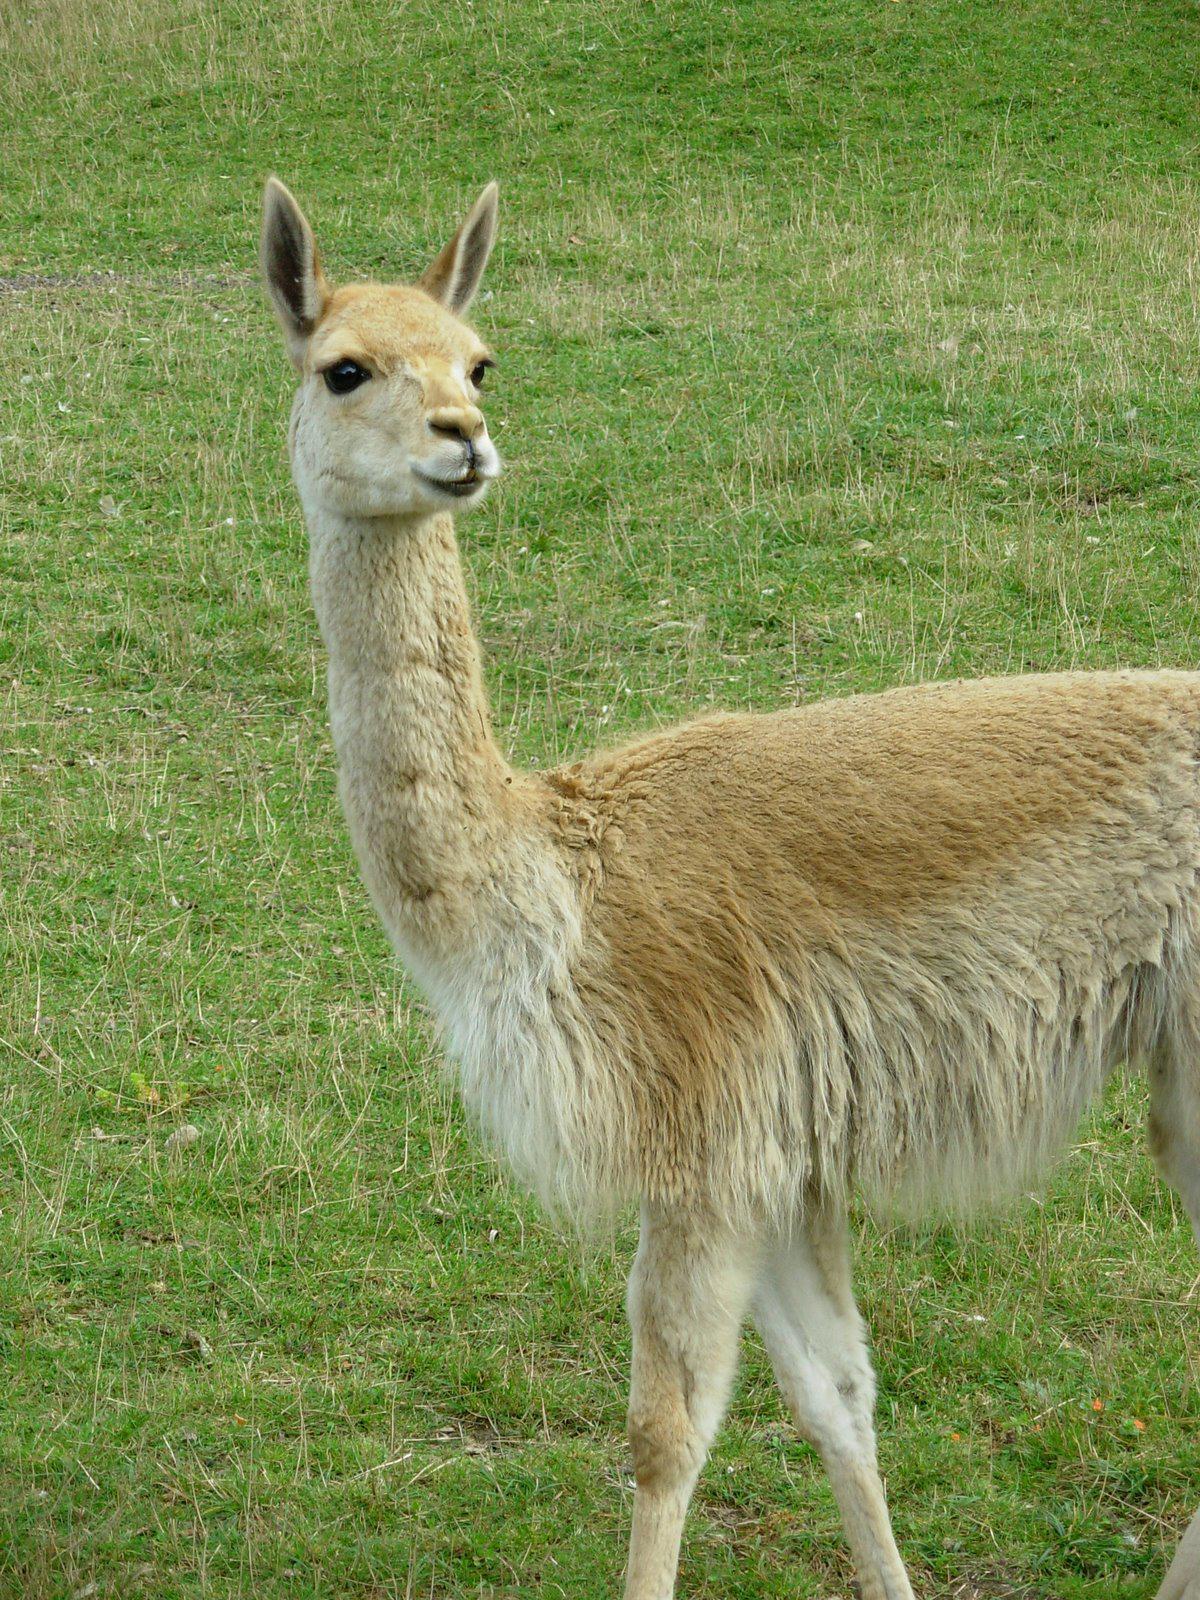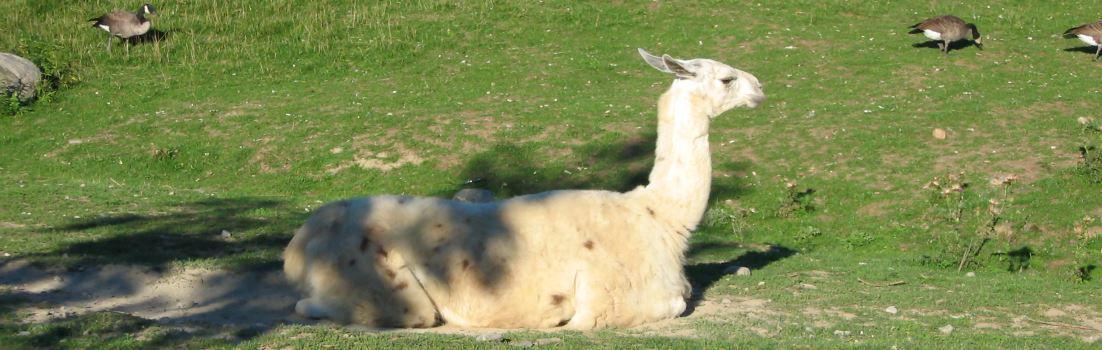The first image is the image on the left, the second image is the image on the right. Given the left and right images, does the statement "The left and right image contains no more than three total llamas." hold true? Answer yes or no. Yes. The first image is the image on the left, the second image is the image on the right. Analyze the images presented: Is the assertion "The right image contains one llama reclining with its body aimed leftward and its pright head turned forward." valid? Answer yes or no. No. 